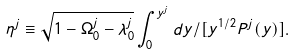<formula> <loc_0><loc_0><loc_500><loc_500>\eta ^ { j } \equiv \sqrt { 1 - \Omega _ { 0 } ^ { j } - \lambda _ { 0 } ^ { j } } \int _ { 0 } ^ { y ^ { j } } d y / [ y ^ { 1 / 2 } P ^ { j } ( y ) ] .</formula> 